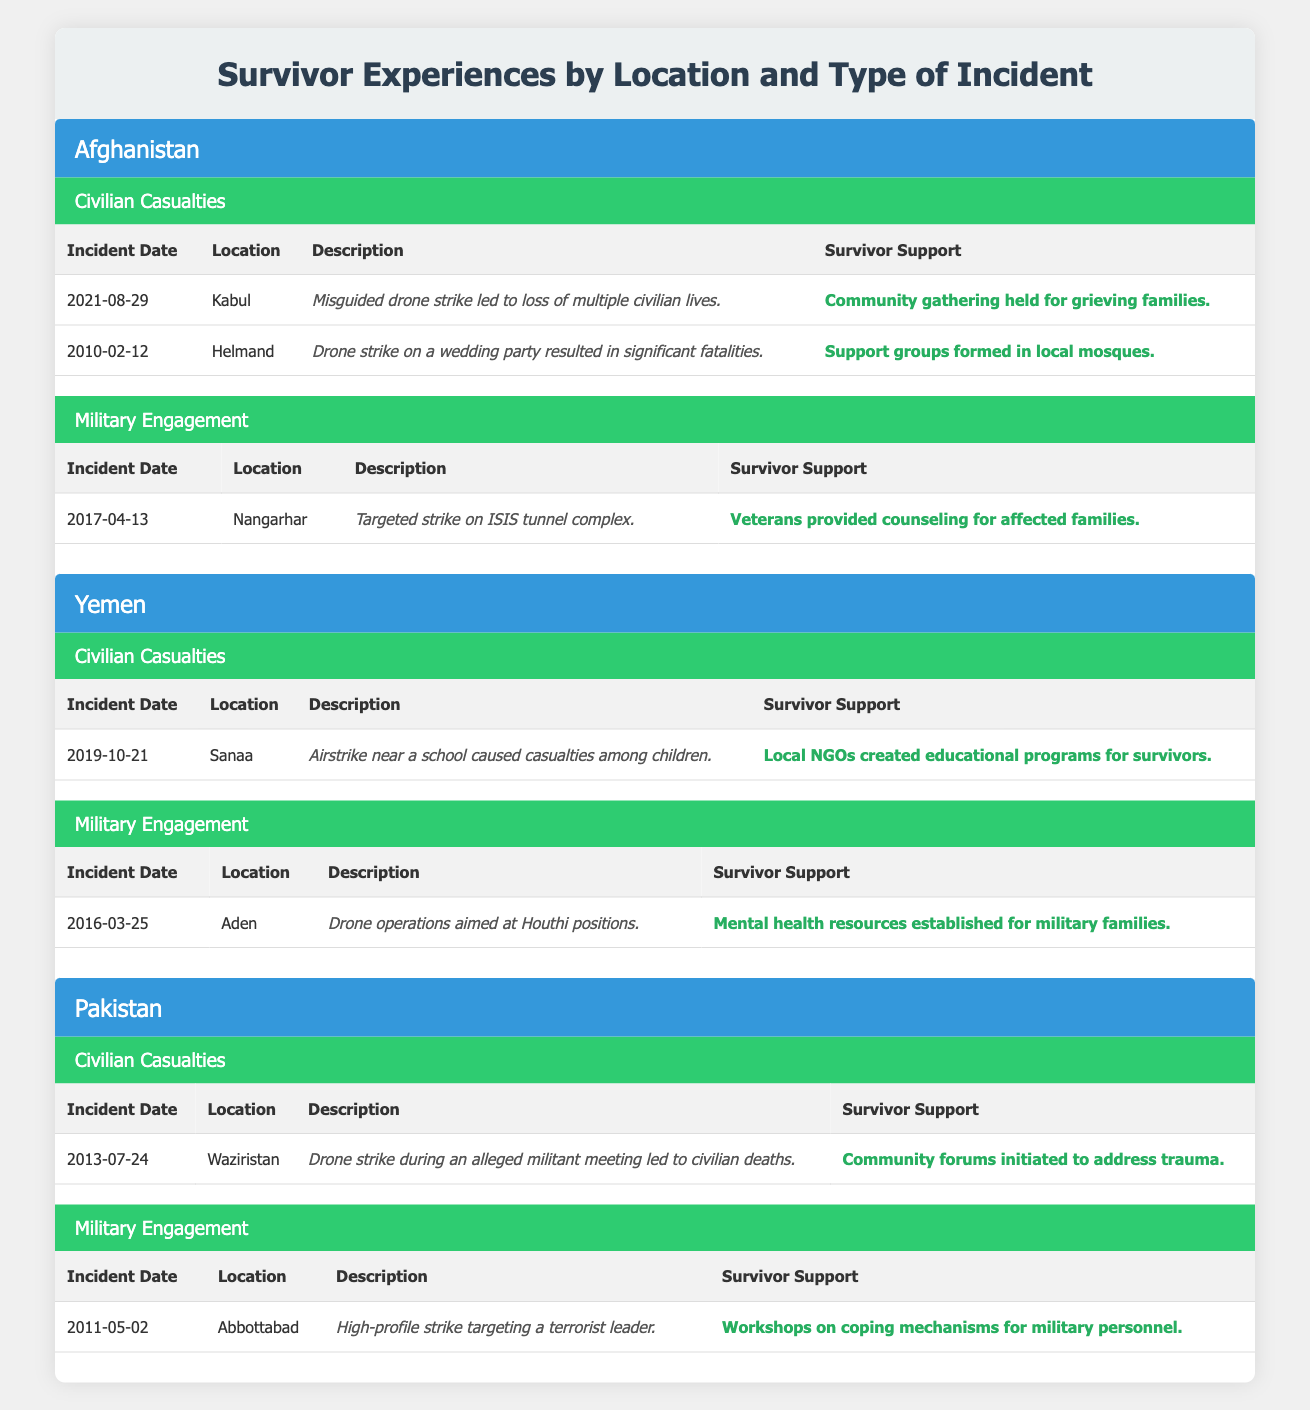What is the location of the first civilian casualties incident in Afghanistan? The first civilian casualties incident in Afghanistan listed in the table is on "2021-08-29" which occurred in "Kabul."
Answer: Kabul How many incidents of civilian casualties are reported in Yemen? Yemen has one reported incident of civilian casualties listed in the table dated "2019-10-21."
Answer: 1 Was there a civilian casualties incident in Pakistan resulting from a strike during a militant meeting? Yes, there is an incident listed on "2013-07-24" in "Waziristan" where a drone strike during an alleged militant meeting led to civilian deaths.
Answer: Yes What type of support was provided to families after the wedding party drone strike in Afghanistan? After the drone strike on a wedding party in Helmand on "2010-02-12", support groups were formed in local mosques for the affected families.
Answer: Support groups formed in local mosques What is the description of the military engagement incident in Yemen? The military engagement incident in Yemen occurred on "2016-03-25" in "Aden," where the description states that drone operations were aimed at Houthi positions.
Answer: Drone operations aimed at Houthi positions Which country experienced the incident on "2011-05-02"? The incident on "2011-05-02" took place in "Abbottabad," Pakistan, where the strike targeted a terrorist leader.
Answer: Pakistan How many total incidents of military engagement are reported in the table? There are four military engagement incidents reported—one each from Afghanistan, Yemen, and Pakistan.
Answer: 3 Which location had the earliest incident report of civilian casualties and what was the date? The earliest reported incident of civilian casualties is from "Afghanistan," dated "2010-02-12" in Helmand.
Answer: Helmand, 2010-02-12 Explain the type of survivor support provided in Afghanistan for the targeted strike on the ISIS tunnel complex. After the targeted strike on the ISIS tunnel complex in Nangarhar on "2017-04-13," veterans provided counseling for affected families, supporting their emotional and psychological needs.
Answer: Veterans provided counseling for affected families 